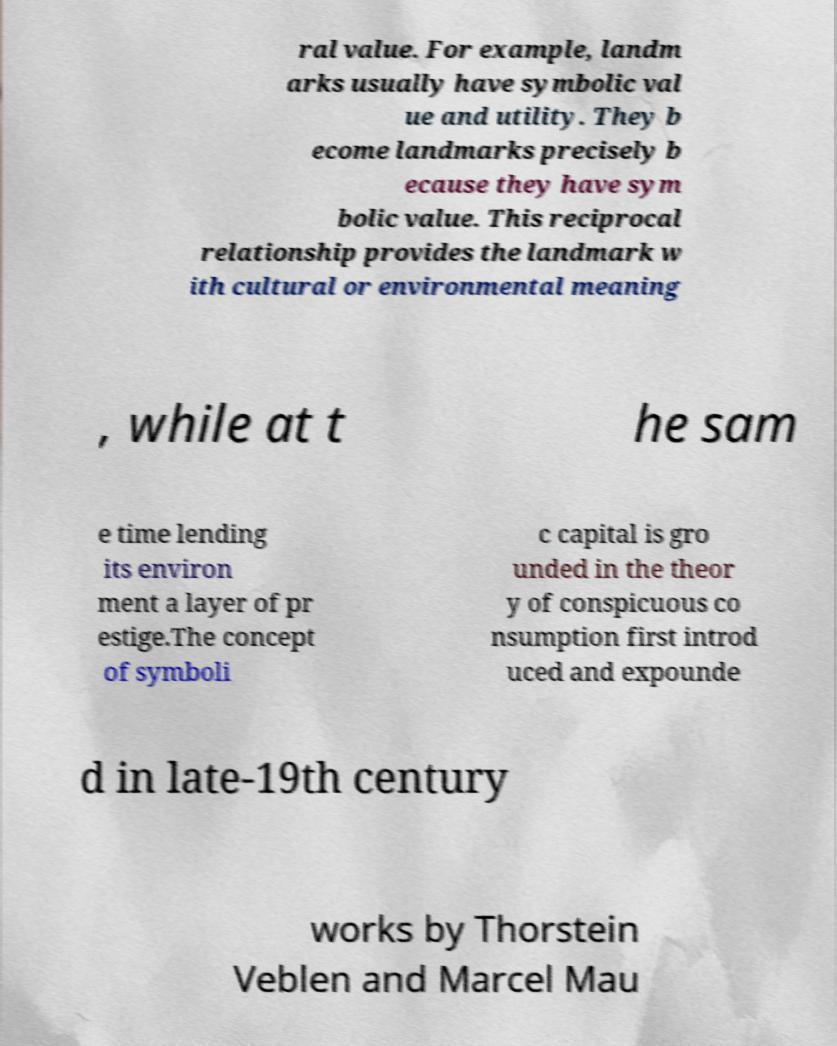Can you read and provide the text displayed in the image?This photo seems to have some interesting text. Can you extract and type it out for me? ral value. For example, landm arks usually have symbolic val ue and utility. They b ecome landmarks precisely b ecause they have sym bolic value. This reciprocal relationship provides the landmark w ith cultural or environmental meaning , while at t he sam e time lending its environ ment a layer of pr estige.The concept of symboli c capital is gro unded in the theor y of conspicuous co nsumption first introd uced and expounde d in late-19th century works by Thorstein Veblen and Marcel Mau 